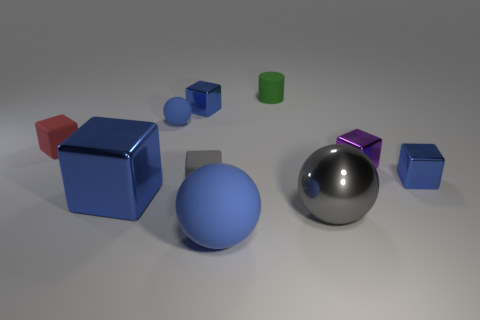Do the big matte ball and the large metallic block have the same color? yes 